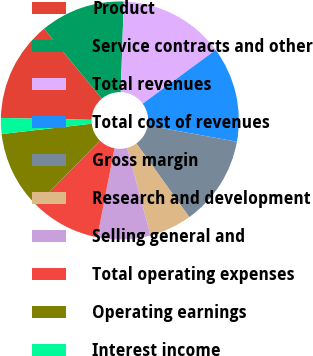Convert chart to OTSL. <chart><loc_0><loc_0><loc_500><loc_500><pie_chart><fcel>Product<fcel>Service contracts and other<fcel>Total revenues<fcel>Total cost of revenues<fcel>Gross margin<fcel>Research and development<fcel>Selling general and<fcel>Total operating expenses<fcel>Operating earnings<fcel>Interest income<nl><fcel>13.67%<fcel>11.51%<fcel>14.39%<fcel>12.95%<fcel>12.23%<fcel>5.76%<fcel>7.19%<fcel>9.35%<fcel>10.79%<fcel>2.16%<nl></chart> 